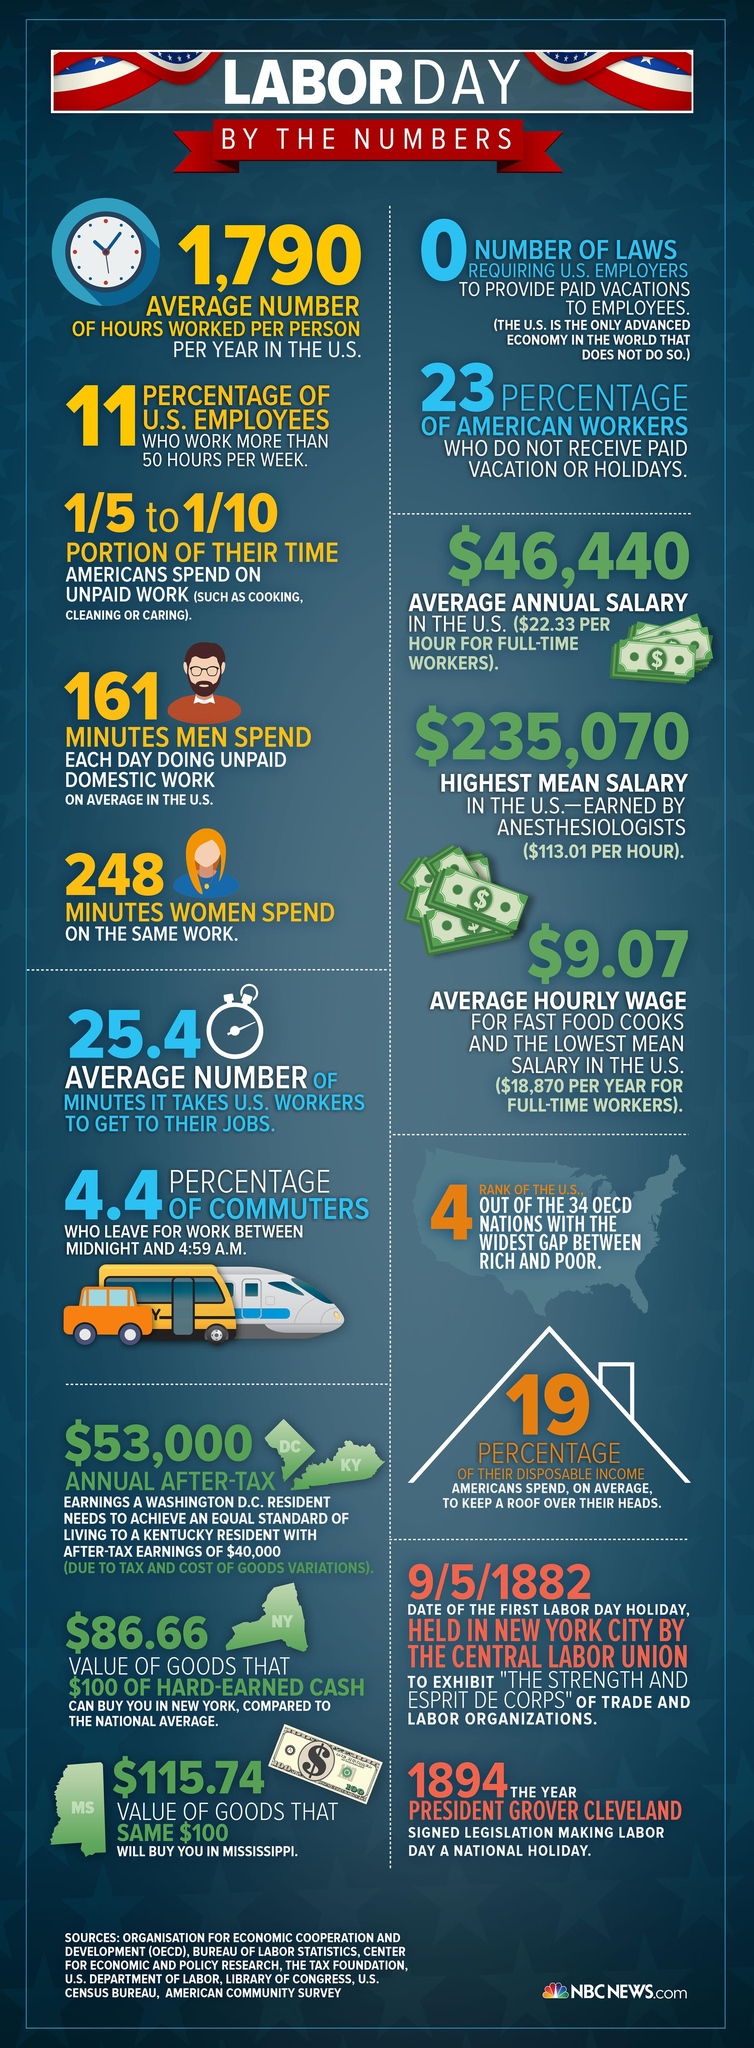Specify some key components in this picture. There are no laws in the United States that require employers to provide paid vacation time to their employees. On average, it takes US workers 25.4 minutes to commute to their jobs. In order to have an equal standard of living, a resident of Washington, D.C. should earn approximately $13,000 more than a resident of Kentucky, according to recent calculations. The mean salary of fast food cooks in the US is the lowest among all professions. According to a recent survey, on average, 19% of the disposable income of Americans is spent on housing in order to maintain a roof over their heads. 